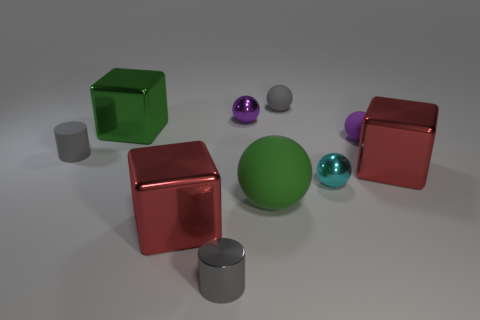Does the tiny object that is to the right of the cyan thing have the same shape as the small metallic object behind the cyan sphere?
Your answer should be very brief. Yes. What color is the small matte cylinder behind the small cyan thing?
Ensure brevity in your answer.  Gray. Are there any other large green metal things that have the same shape as the big green metal object?
Give a very brief answer. No. What is the material of the large green block?
Ensure brevity in your answer.  Metal. What is the size of the metallic thing that is in front of the big rubber ball and behind the tiny metal cylinder?
Keep it short and to the point. Large. There is another small cylinder that is the same color as the matte cylinder; what material is it?
Offer a very short reply. Metal. How many blue metal objects are there?
Give a very brief answer. 0. Is the number of big metal blocks less than the number of purple shiny balls?
Offer a terse response. No. There is a cyan thing that is the same size as the purple shiny thing; what material is it?
Keep it short and to the point. Metal. How many things are either spheres or shiny things?
Your answer should be compact. 9. 